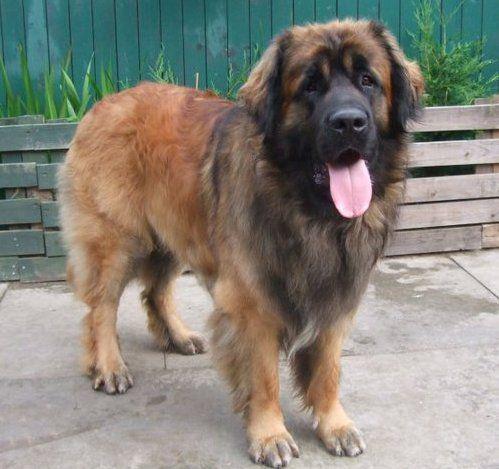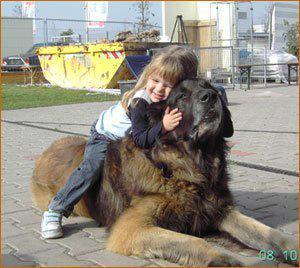The first image is the image on the left, the second image is the image on the right. Evaluate the accuracy of this statement regarding the images: "A human is petting a dog.". Is it true? Answer yes or no. Yes. The first image is the image on the left, the second image is the image on the right. For the images displayed, is the sentence "An image includes a person behind a dog's head, with a hand near the side of the dog's head." factually correct? Answer yes or no. Yes. 